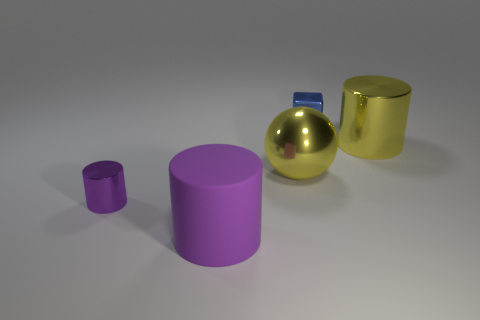There is a tiny object that is behind the cylinder that is behind the small purple object; what is its color?
Offer a very short reply. Blue. How many yellow things are there?
Provide a succinct answer. 2. What number of shiny things are purple things or tiny purple objects?
Offer a terse response. 1. What number of things have the same color as the large sphere?
Make the answer very short. 1. What is the material of the large yellow object that is to the left of the big cylinder that is on the right side of the large rubber thing?
Your answer should be compact. Metal. How big is the purple shiny cylinder?
Make the answer very short. Small. How many yellow matte objects have the same size as the yellow ball?
Make the answer very short. 0. How many purple rubber things have the same shape as the tiny purple metallic thing?
Your answer should be compact. 1. Is the number of large objects that are to the right of the big yellow cylinder the same as the number of cyan metal cylinders?
Keep it short and to the point. Yes. What is the shape of the blue metallic thing that is the same size as the purple shiny thing?
Provide a succinct answer. Cube. 